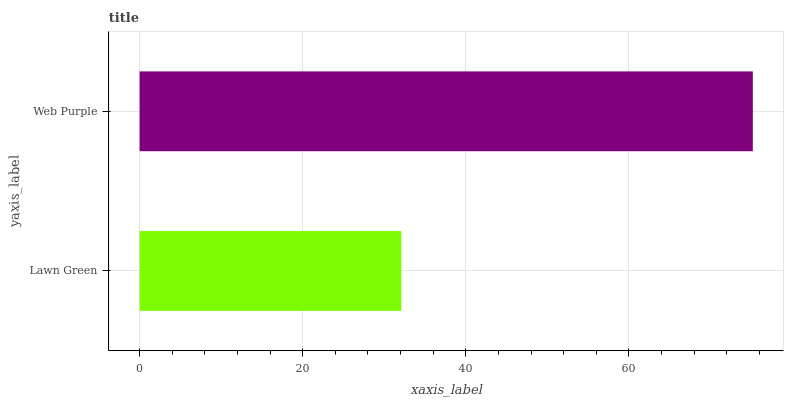Is Lawn Green the minimum?
Answer yes or no. Yes. Is Web Purple the maximum?
Answer yes or no. Yes. Is Web Purple the minimum?
Answer yes or no. No. Is Web Purple greater than Lawn Green?
Answer yes or no. Yes. Is Lawn Green less than Web Purple?
Answer yes or no. Yes. Is Lawn Green greater than Web Purple?
Answer yes or no. No. Is Web Purple less than Lawn Green?
Answer yes or no. No. Is Web Purple the high median?
Answer yes or no. Yes. Is Lawn Green the low median?
Answer yes or no. Yes. Is Lawn Green the high median?
Answer yes or no. No. Is Web Purple the low median?
Answer yes or no. No. 